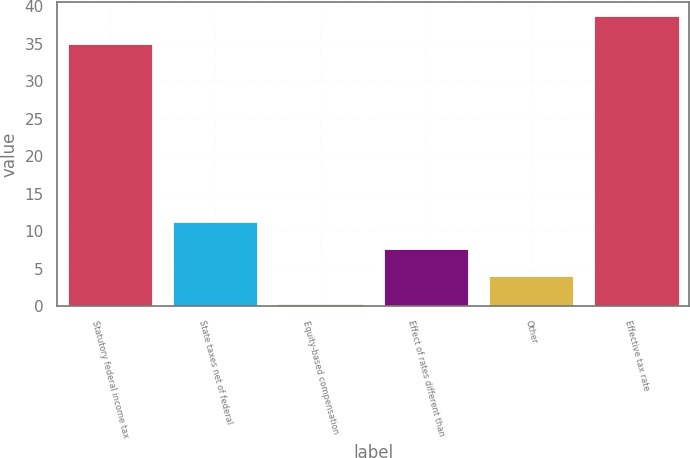<chart> <loc_0><loc_0><loc_500><loc_500><bar_chart><fcel>Statutory federal income tax<fcel>State taxes net of federal<fcel>Equity-based compensation<fcel>Effect of rates different than<fcel>Other<fcel>Effective tax rate<nl><fcel>35<fcel>11.25<fcel>0.3<fcel>7.6<fcel>3.95<fcel>38.65<nl></chart> 